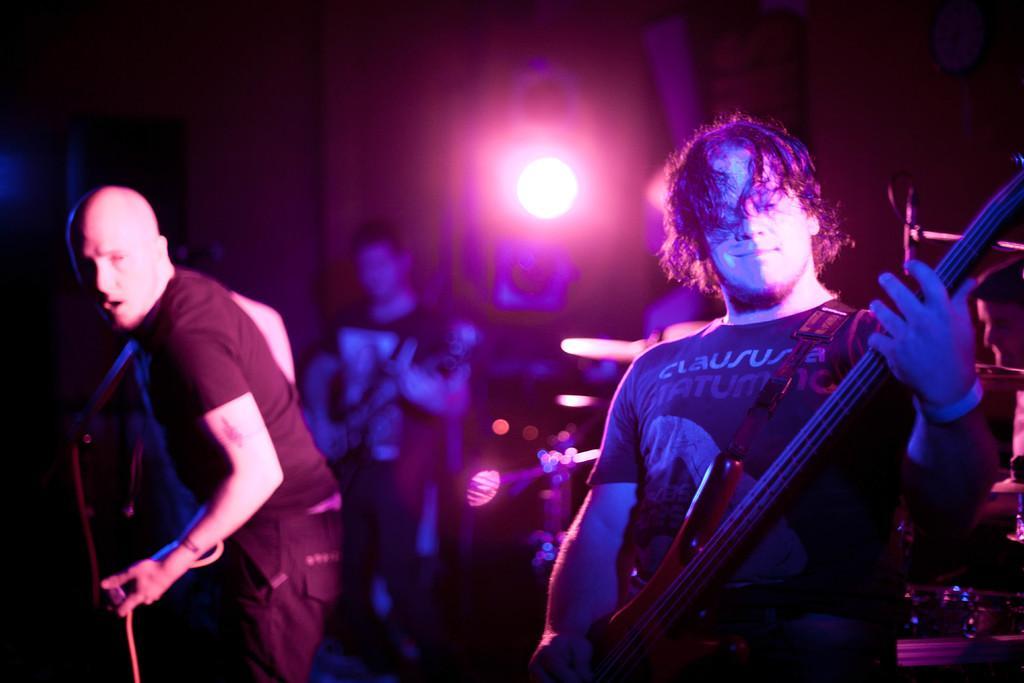In one or two sentences, can you explain what this image depicts? As we can see in he image there is a light and three people standing and holding guitars in their hands. 